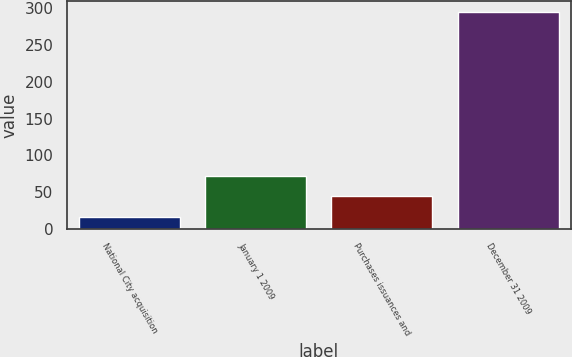Convert chart to OTSL. <chart><loc_0><loc_0><loc_500><loc_500><bar_chart><fcel>National City acquisition<fcel>January 1 2009<fcel>Purchases issuances and<fcel>December 31 2009<nl><fcel>16<fcel>71.8<fcel>43.9<fcel>295<nl></chart> 